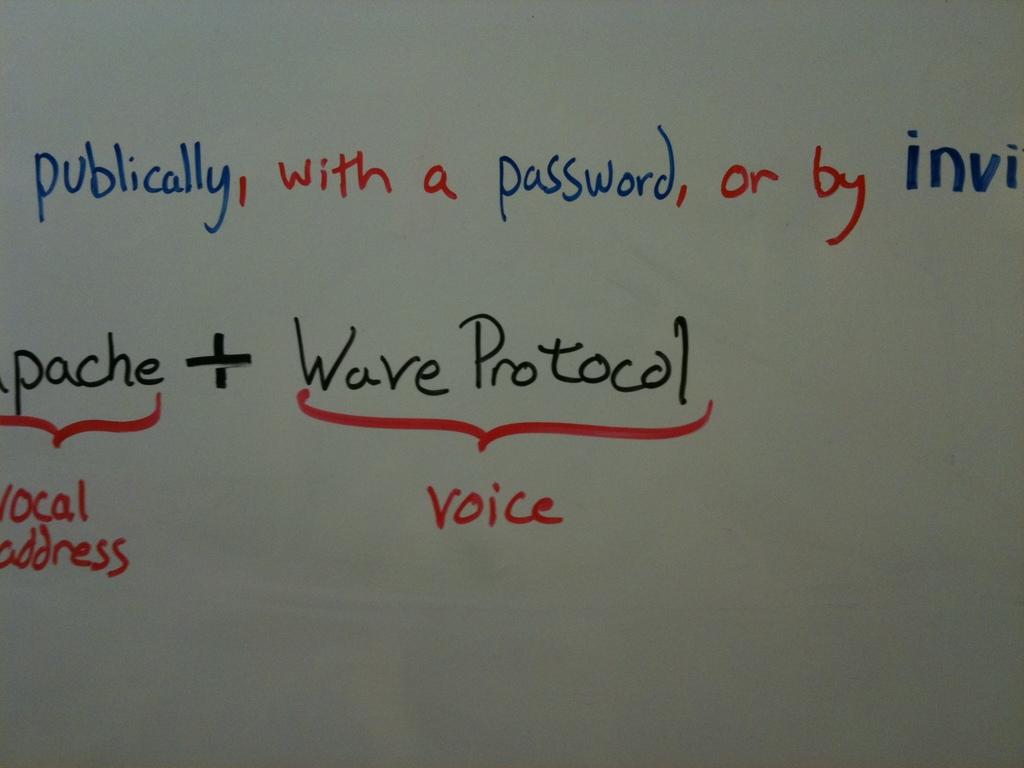What protocol is mentioned?
Provide a short and direct response. Wave. What is the first word on the upper left?
Provide a succinct answer. Publically. 